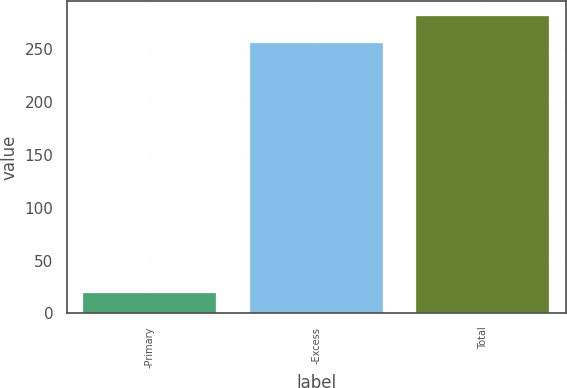Convert chart. <chart><loc_0><loc_0><loc_500><loc_500><bar_chart><fcel>-Primary<fcel>-Excess<fcel>Total<nl><fcel>19<fcel>256<fcel>281.6<nl></chart> 